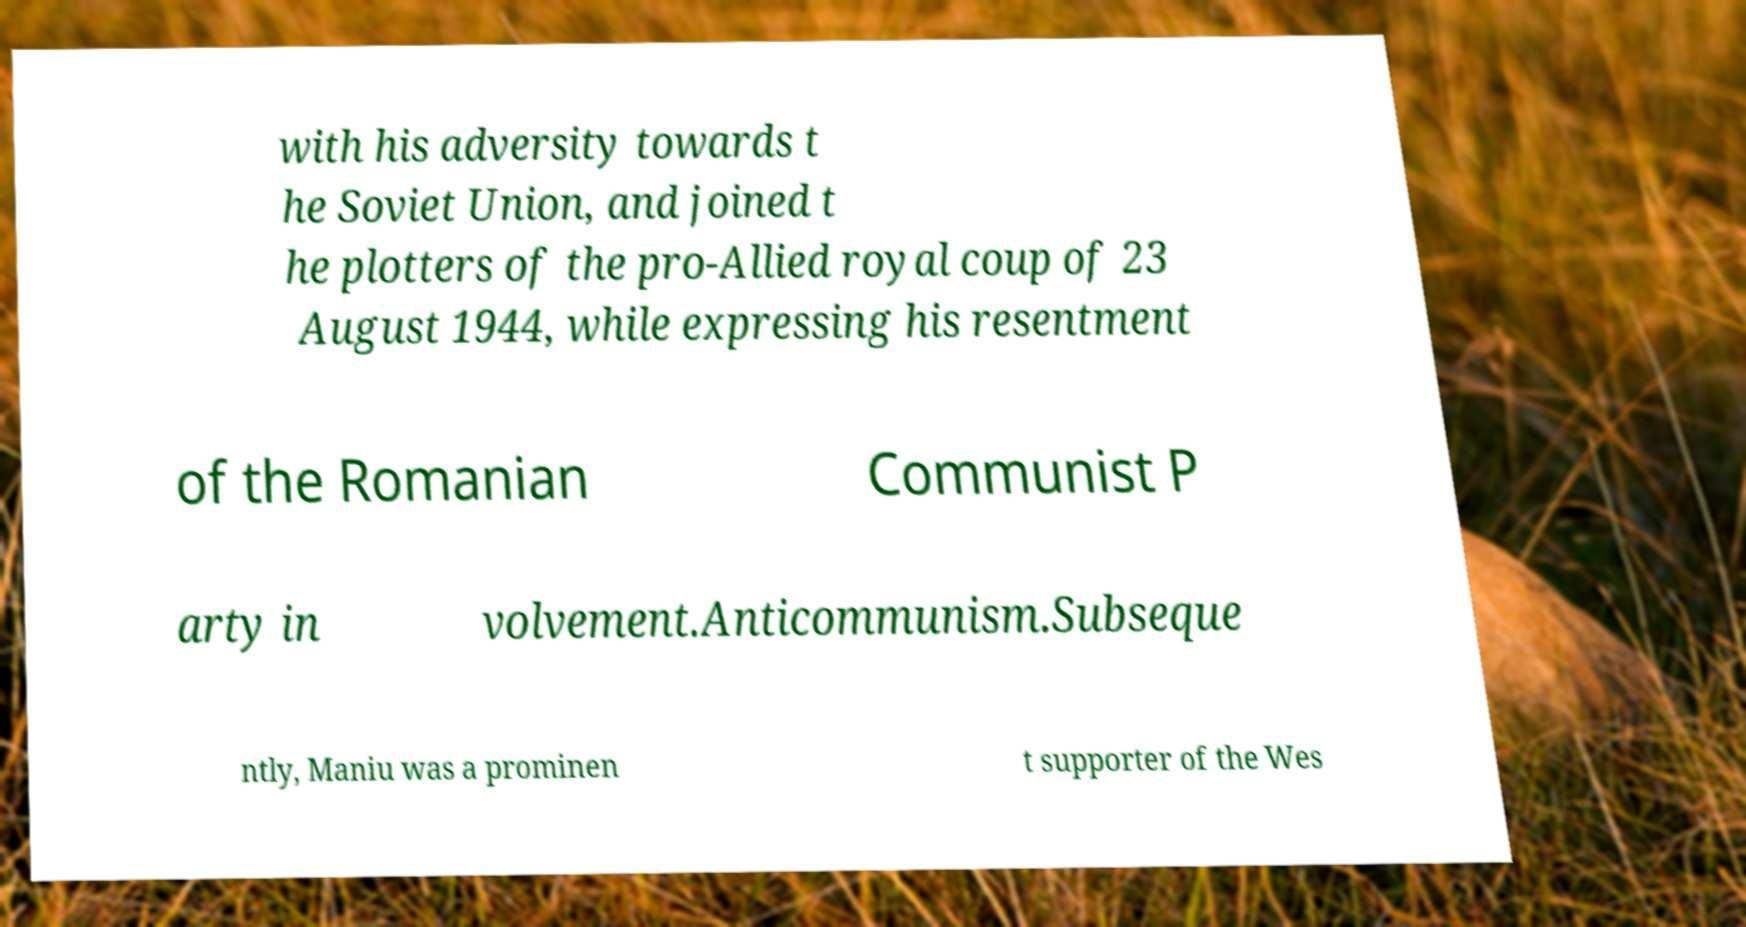Can you read and provide the text displayed in the image?This photo seems to have some interesting text. Can you extract and type it out for me? with his adversity towards t he Soviet Union, and joined t he plotters of the pro-Allied royal coup of 23 August 1944, while expressing his resentment of the Romanian Communist P arty in volvement.Anticommunism.Subseque ntly, Maniu was a prominen t supporter of the Wes 